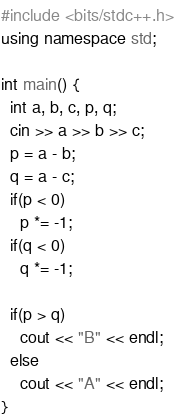Convert code to text. <code><loc_0><loc_0><loc_500><loc_500><_C++_>#include <bits/stdc++.h>
using namespace std;

int main() {
  int a, b, c, p, q;
  cin >> a >> b >> c;
  p = a - b;
  q = a - c;
  if(p < 0)
    p *= -1;
  if(q < 0)
    q *= -1;
  
  if(p > q)
    cout << "B" << endl;
  else
    cout << "A" << endl;
}</code> 